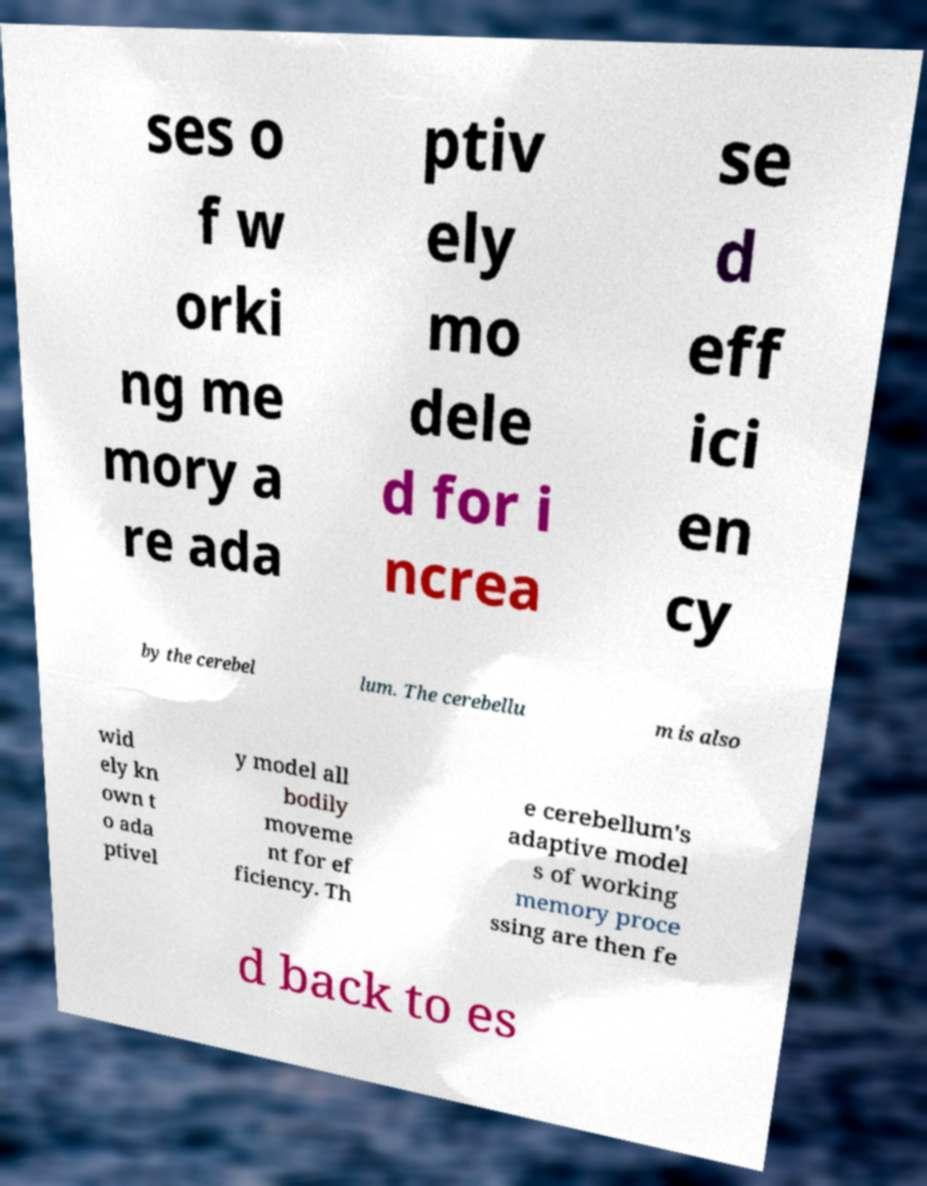Can you read and provide the text displayed in the image?This photo seems to have some interesting text. Can you extract and type it out for me? ses o f w orki ng me mory a re ada ptiv ely mo dele d for i ncrea se d eff ici en cy by the cerebel lum. The cerebellu m is also wid ely kn own t o ada ptivel y model all bodily moveme nt for ef ficiency. Th e cerebellum's adaptive model s of working memory proce ssing are then fe d back to es 